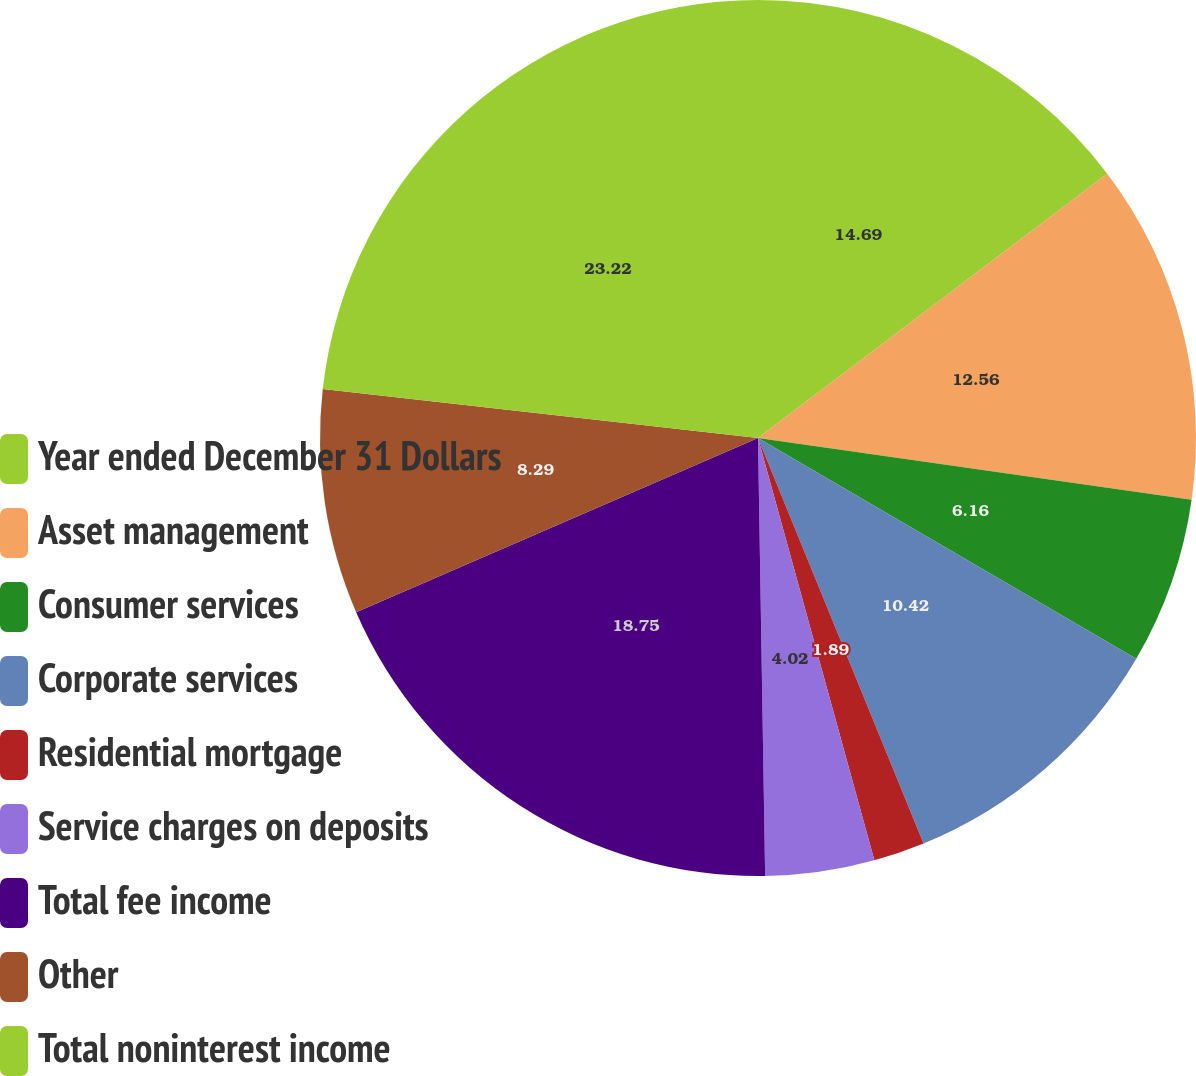<chart> <loc_0><loc_0><loc_500><loc_500><pie_chart><fcel>Year ended December 31 Dollars<fcel>Asset management<fcel>Consumer services<fcel>Corporate services<fcel>Residential mortgage<fcel>Service charges on deposits<fcel>Total fee income<fcel>Other<fcel>Total noninterest income<nl><fcel>14.69%<fcel>12.56%<fcel>6.16%<fcel>10.42%<fcel>1.89%<fcel>4.02%<fcel>18.75%<fcel>8.29%<fcel>23.22%<nl></chart> 